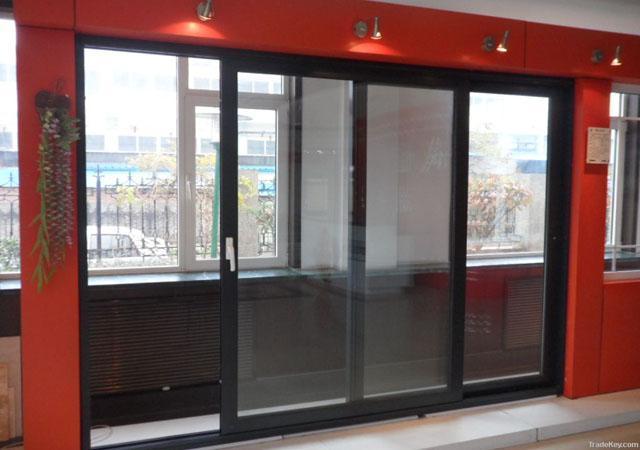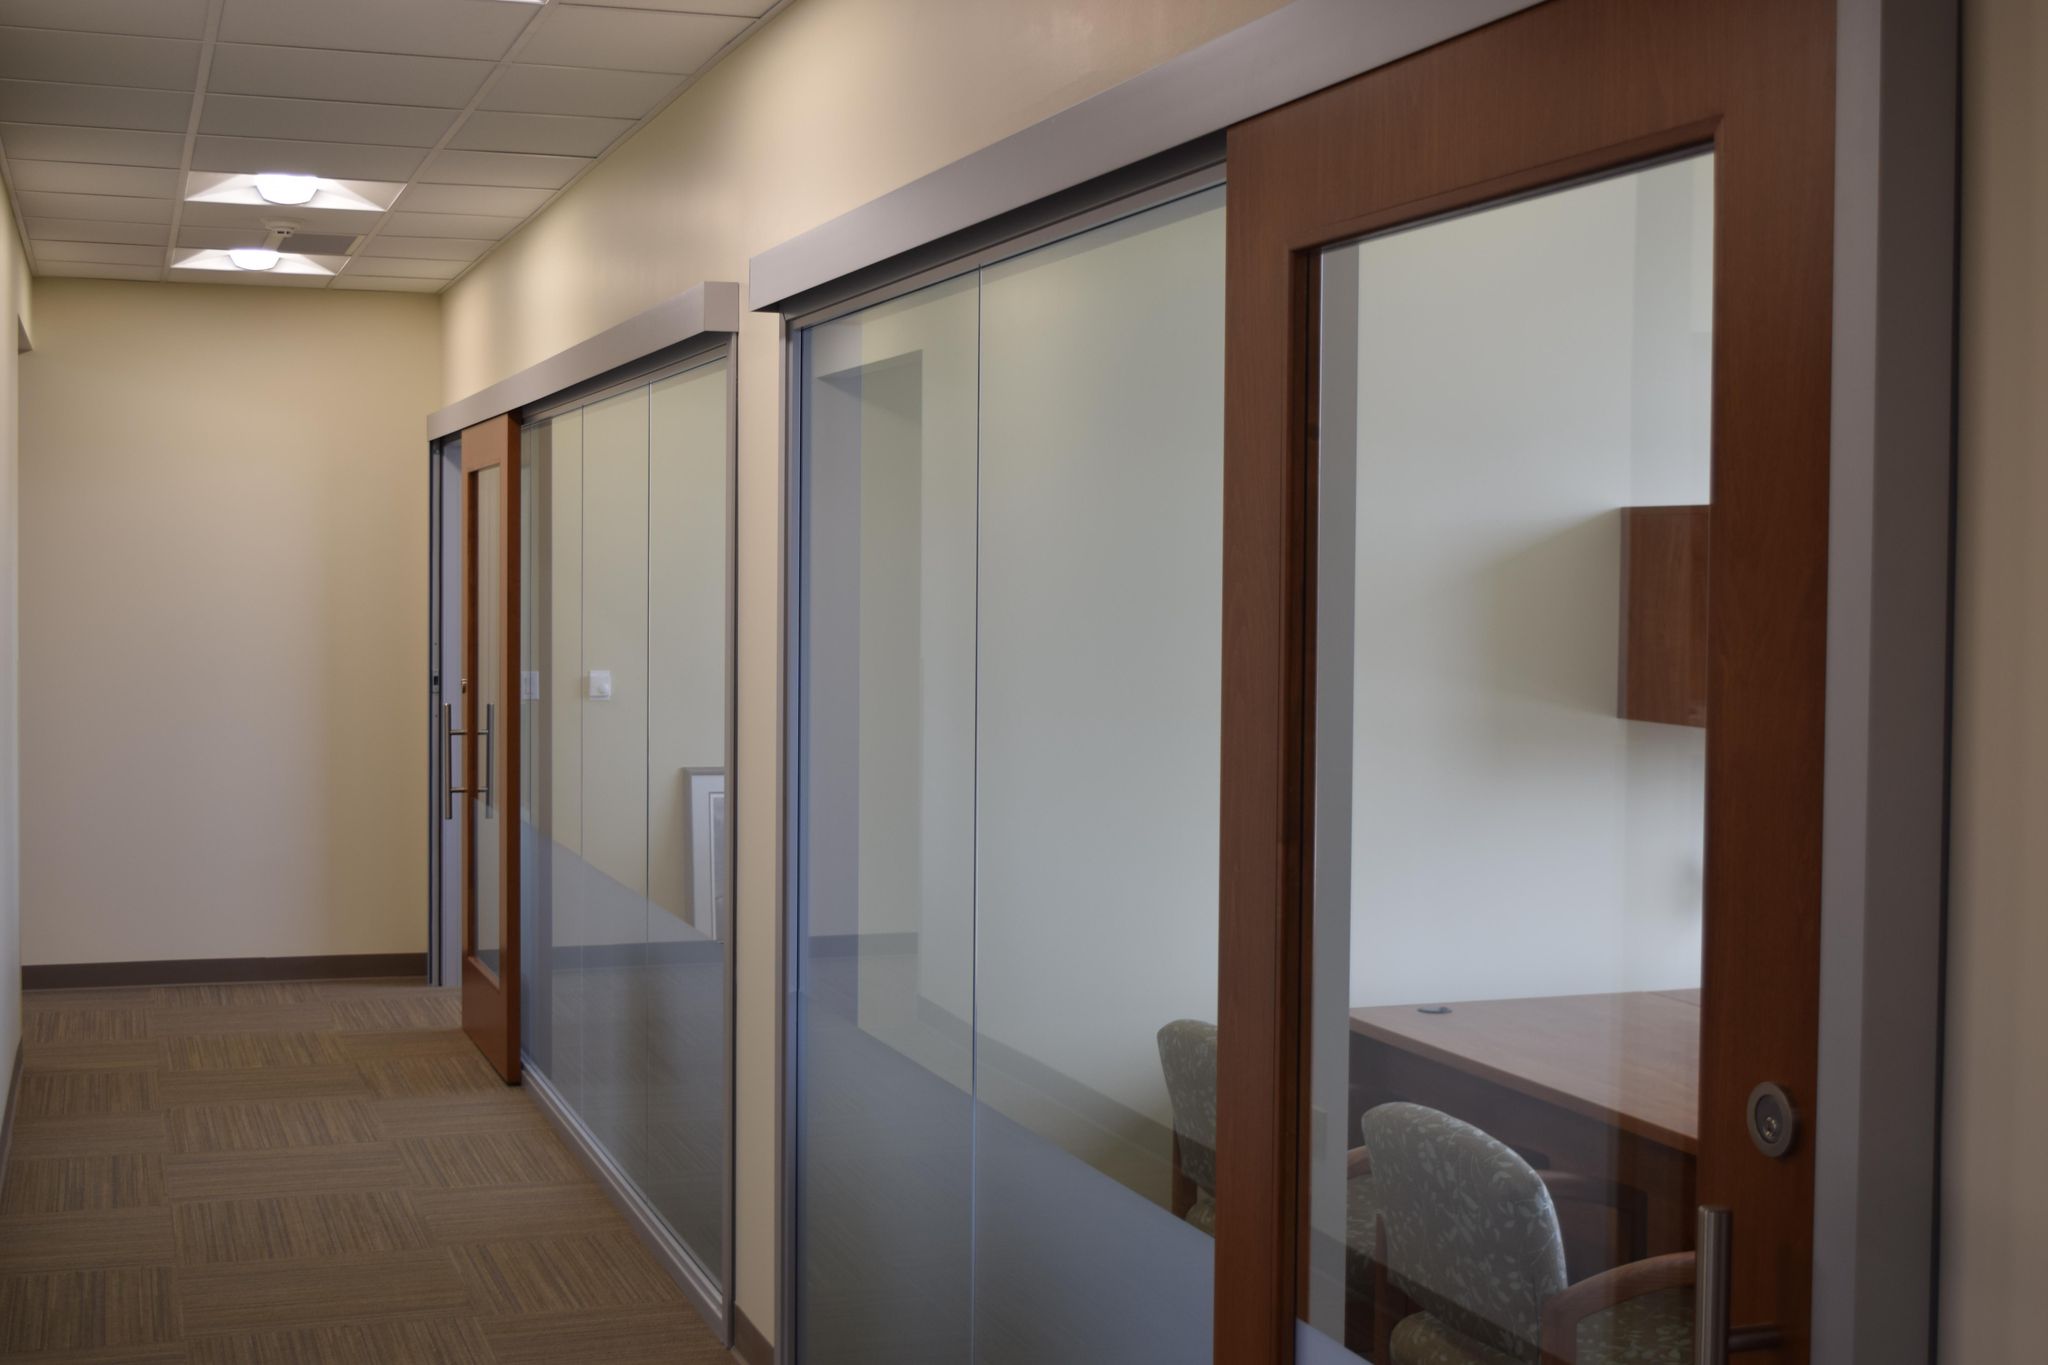The first image is the image on the left, the second image is the image on the right. Given the left and right images, does the statement "The left and right image contains a total of three dogs with two identical one on top of each other." hold true? Answer yes or no. No. The first image is the image on the left, the second image is the image on the right. Examine the images to the left and right. Is the description "One of the images is split; the same door is being shown both open, and closed." accurate? Answer yes or no. No. 